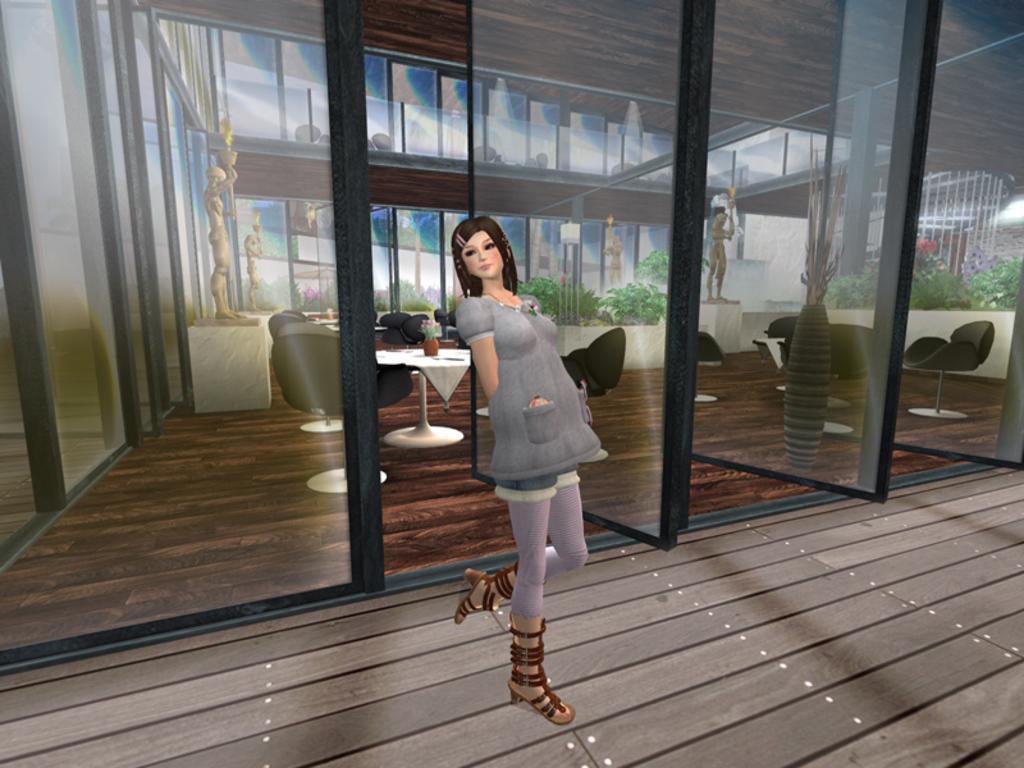Describe this image in one or two sentences. This is an animation picture. In this image there is a woman standing. At the back behind the glass wall there are tables and chairs and there is a flower vase on the table and there are statues and plants. At the bottom there is a wooden floor. 